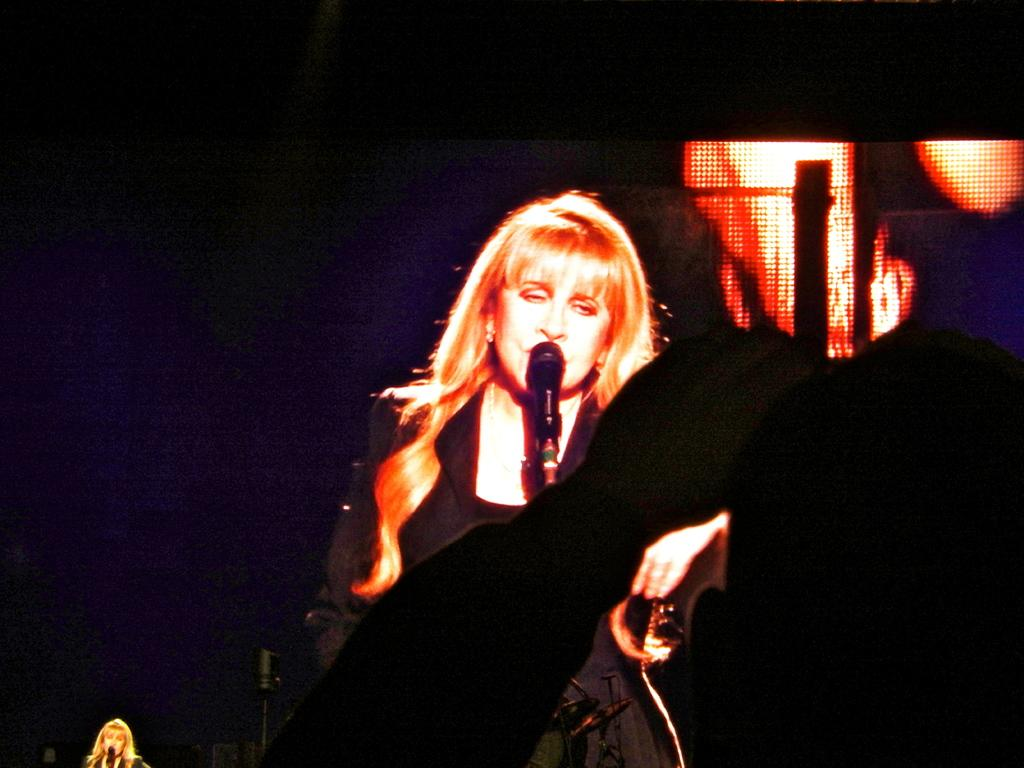What is the color of the background in the image? The background of the image is dark. Can you describe the woman in the image? The woman in the image is wearing a black dress. What object is present in the image that is typically used for amplifying sound? There is a microphone (mike) in the image. Where are the woman and the microphone located in the image? The woman and the microphone are located at the bottom left corner of the image. Is there a ghost visible in the image, standing next to the woman? No, there is no ghost present in the image. 